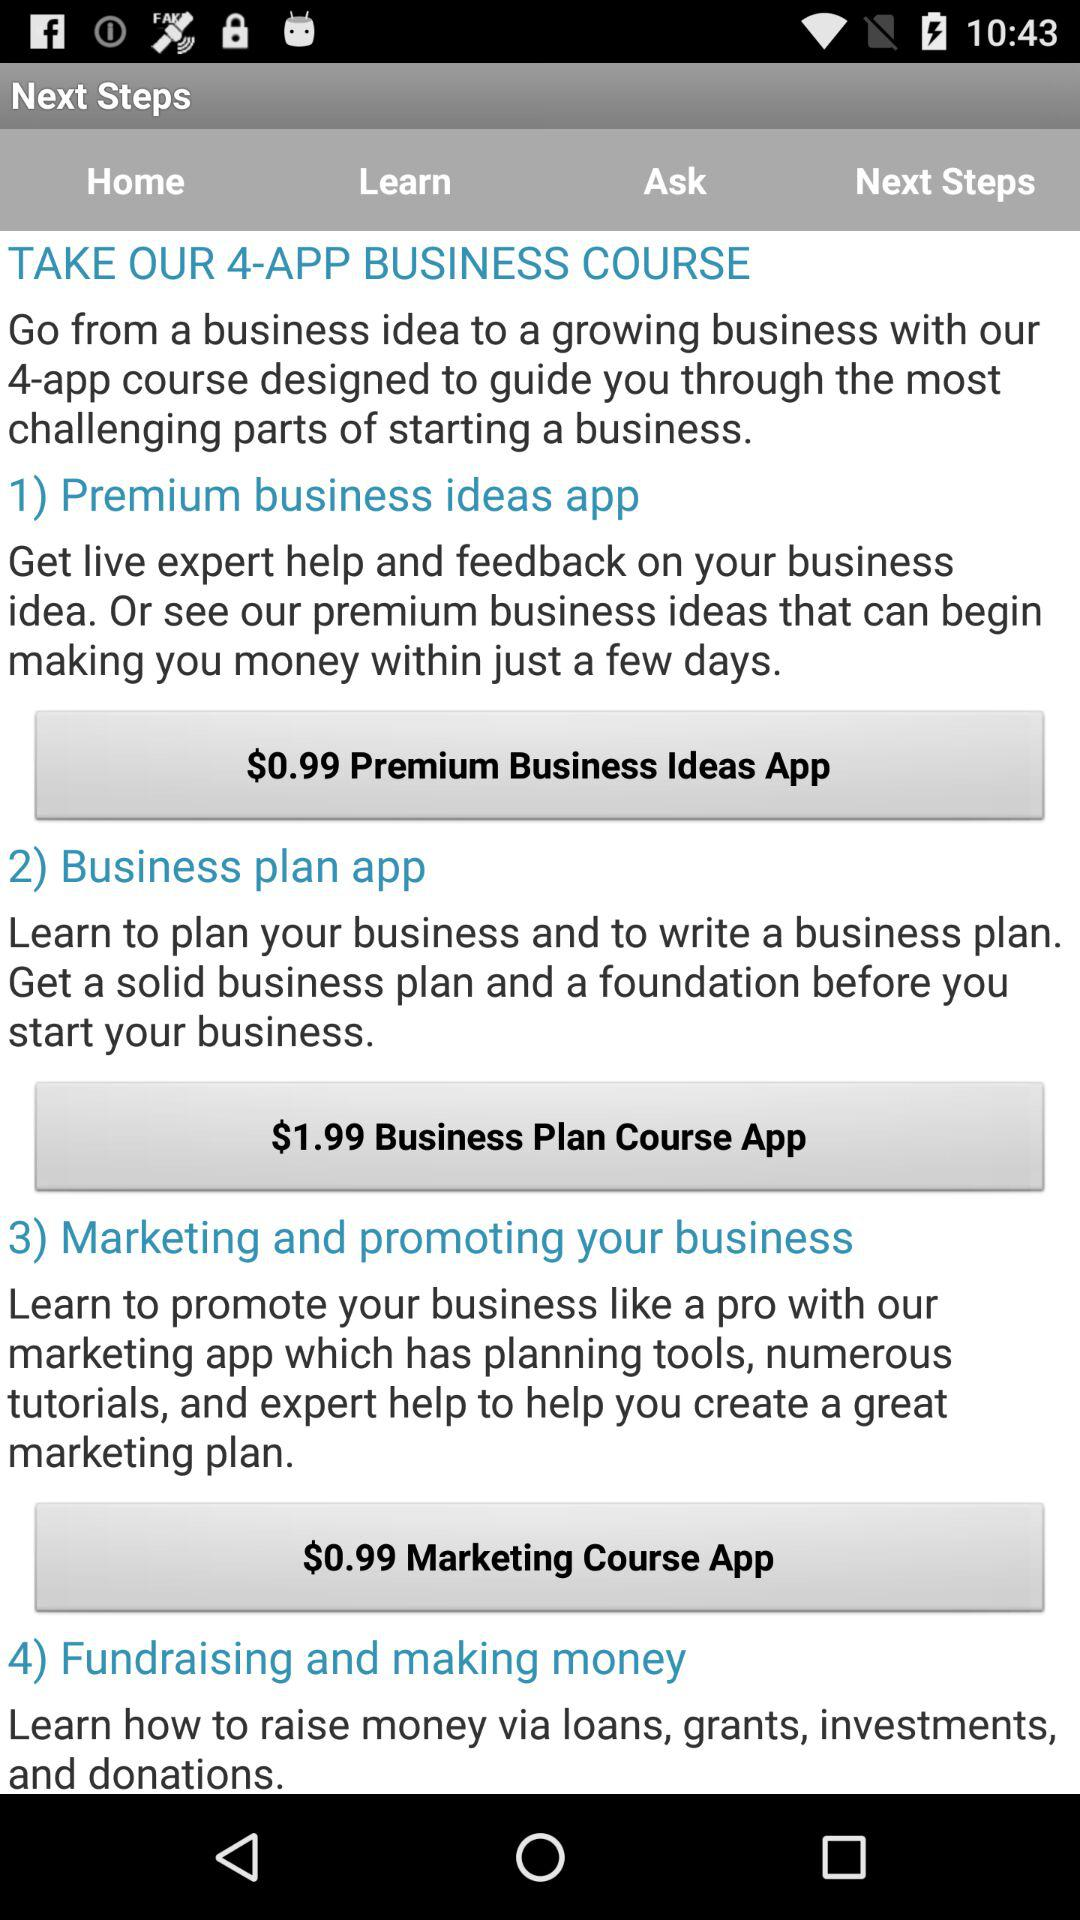How many business course apps are there?
Answer the question using a single word or phrase. 4 